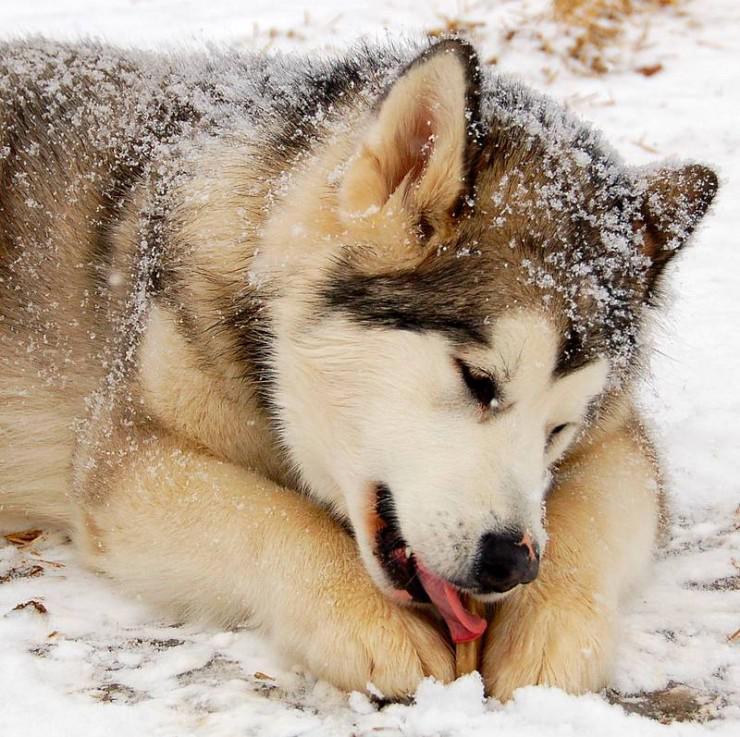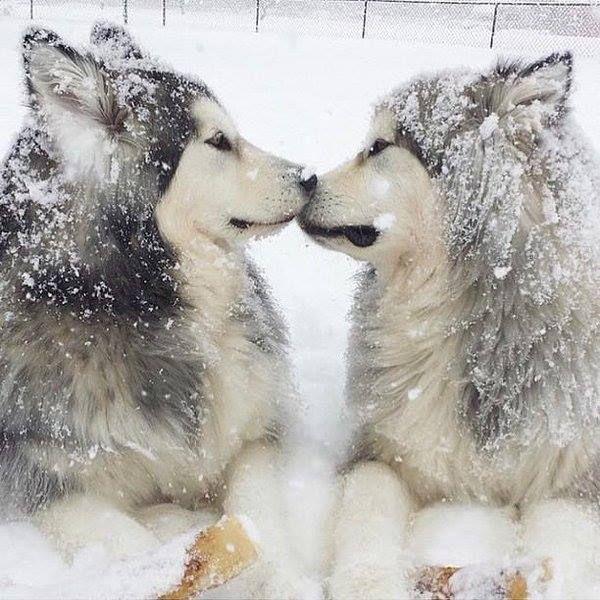The first image is the image on the left, the second image is the image on the right. Examine the images to the left and right. Is the description "Two of the huskies are touching faces with each other in snowy weather." accurate? Answer yes or no. Yes. 